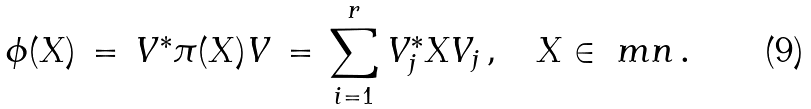<formula> <loc_0><loc_0><loc_500><loc_500>\phi ( X ) \, = \, V ^ { * } \pi ( X ) V \, = \, \sum _ { i = 1 } ^ { r } V _ { j } ^ { * } X V _ { j } \, , \quad X \in \ m n \, .</formula> 